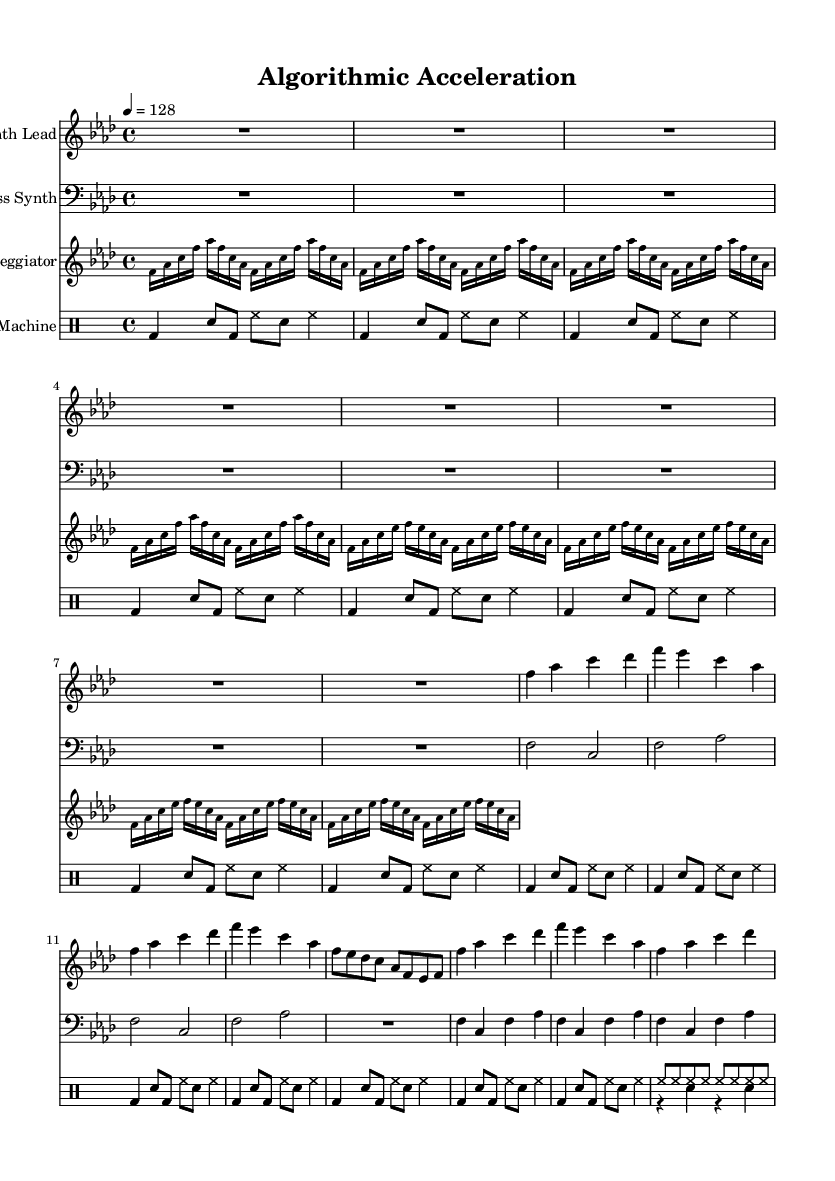What is the key signature of this music? The key signature is indicated by the number of flats shown at the beginning of the staff. In this case, there are four flats, which corresponds to F minor.
Answer: F minor What is the time signature of this music? The time signature is located at the beginning of the music and is shown as 4/4, indicating four beats per measure and a quarter note receives one beat.
Answer: 4/4 What is the tempo marking for this music? The tempo marking is shown near the beginning above the staff, indicating the speed of the piece. Here, it is marked as "4 = 128," meaning there are 128 beats per minute.
Answer: 128 How many measures are in the "Synth Lead" section? By counting the number of bar lines in the "Synth Lead" part, I can see there are a total of eight measures or bars present in this section.
Answer: 8 What rhythmic subdivision is used in the "Arpeggiator"? The "Arpeggiator" section employs sixteenth notes, as indicated by the note heads and the use of the number "16" next to the notes, which specifies the subdivision.
Answer: Sixteenth notes What kind of drum pattern is primarily used in the "Drum Machine"? Observing the rhythmic notation in the "Drum Machine," it primarily uses a pattern that combines bass drums and snare drums, which is typical for house music to maintain a consistent beat.
Answer: Bass and snare Which instruments are featured in the score? The score features four different lines, each represented by unique instrument names: "Synth Lead," "Bass Synth," "Arpeggiator," and "Drum Machine." This can be determined by looking at the instrument names above each staff.
Answer: Synth Lead, Bass Synth, Arpeggiator, Drum Machine 